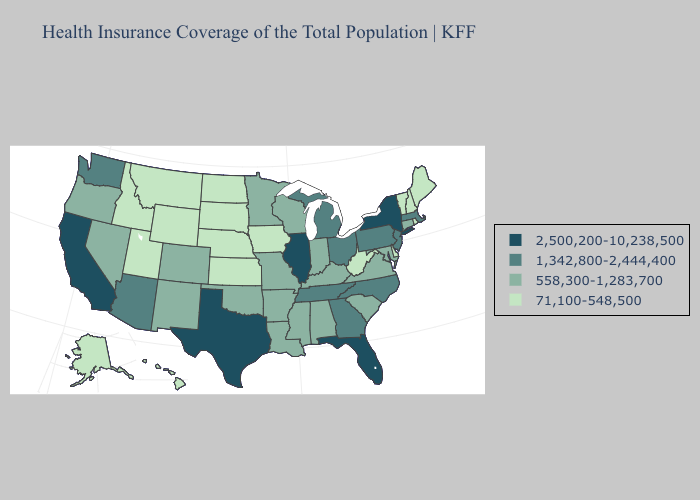What is the value of Maryland?
Be succinct. 558,300-1,283,700. Does Louisiana have the lowest value in the South?
Keep it brief. No. Among the states that border New Mexico , does Texas have the lowest value?
Be succinct. No. Name the states that have a value in the range 71,100-548,500?
Give a very brief answer. Alaska, Delaware, Hawaii, Idaho, Iowa, Kansas, Maine, Montana, Nebraska, New Hampshire, North Dakota, Rhode Island, South Dakota, Utah, Vermont, West Virginia, Wyoming. What is the highest value in states that border Idaho?
Keep it brief. 1,342,800-2,444,400. What is the highest value in the MidWest ?
Quick response, please. 2,500,200-10,238,500. Which states have the highest value in the USA?
Quick response, please. California, Florida, Illinois, New York, Texas. Name the states that have a value in the range 2,500,200-10,238,500?
Short answer required. California, Florida, Illinois, New York, Texas. Name the states that have a value in the range 2,500,200-10,238,500?
Concise answer only. California, Florida, Illinois, New York, Texas. Which states have the highest value in the USA?
Keep it brief. California, Florida, Illinois, New York, Texas. Does California have the highest value in the USA?
Keep it brief. Yes. Which states hav the highest value in the MidWest?
Short answer required. Illinois. What is the value of New Hampshire?
Be succinct. 71,100-548,500. What is the lowest value in states that border Texas?
Short answer required. 558,300-1,283,700. Does Connecticut have a lower value than New York?
Short answer required. Yes. 